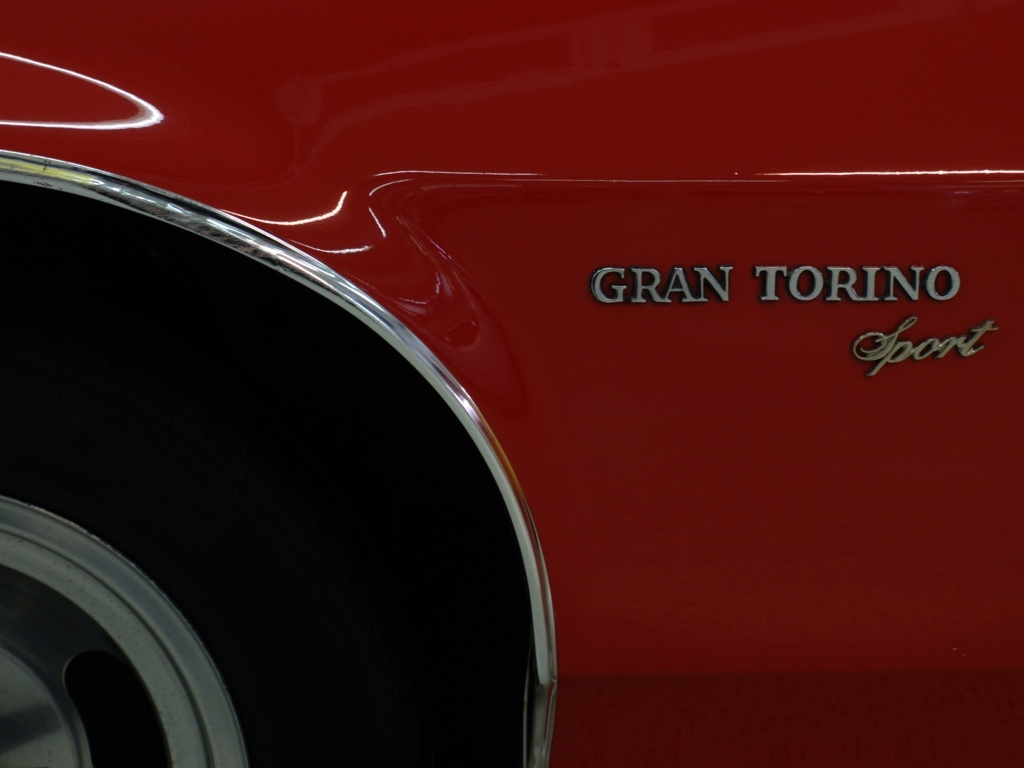Are the colors dull?
A. No
B. Yes
Answer with the option's letter from the given choices directly.
 A. 